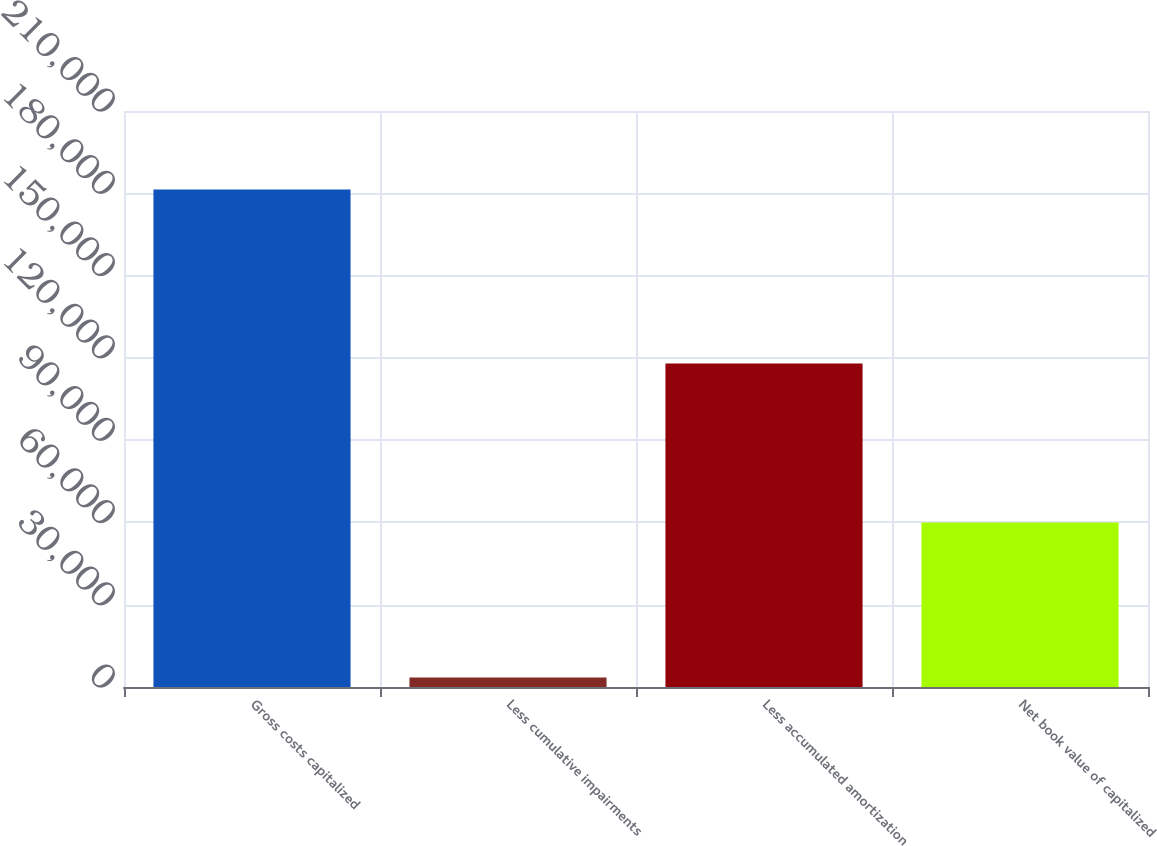Convert chart to OTSL. <chart><loc_0><loc_0><loc_500><loc_500><bar_chart><fcel>Gross costs capitalized<fcel>Less cumulative impairments<fcel>Less accumulated amortization<fcel>Net book value of capitalized<nl><fcel>181376<fcel>3458<fcel>117936<fcel>59982<nl></chart> 